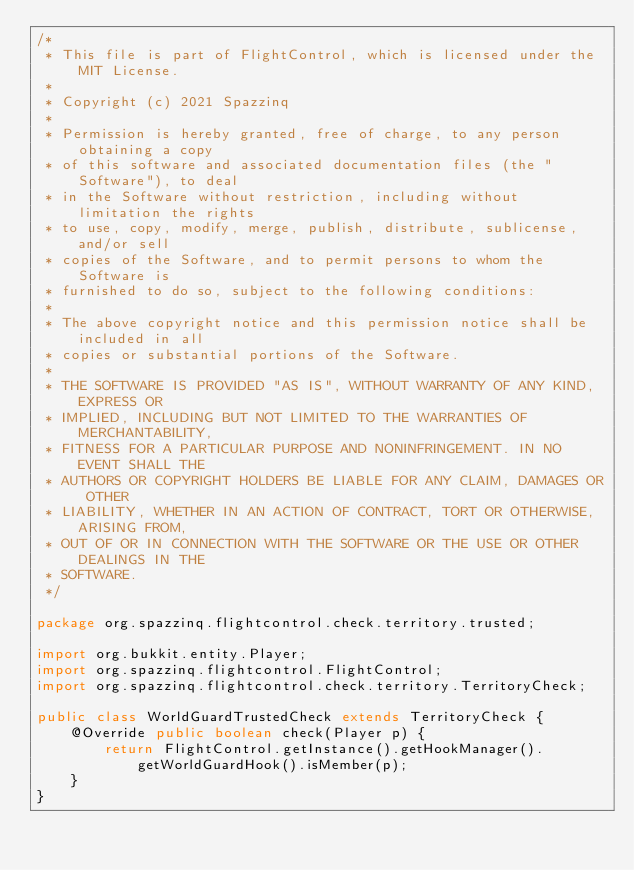<code> <loc_0><loc_0><loc_500><loc_500><_Java_>/*
 * This file is part of FlightControl, which is licensed under the MIT License.
 *
 * Copyright (c) 2021 Spazzinq
 *
 * Permission is hereby granted, free of charge, to any person obtaining a copy
 * of this software and associated documentation files (the "Software"), to deal
 * in the Software without restriction, including without limitation the rights
 * to use, copy, modify, merge, publish, distribute, sublicense, and/or sell
 * copies of the Software, and to permit persons to whom the Software is
 * furnished to do so, subject to the following conditions:
 *
 * The above copyright notice and this permission notice shall be included in all
 * copies or substantial portions of the Software.
 *
 * THE SOFTWARE IS PROVIDED "AS IS", WITHOUT WARRANTY OF ANY KIND, EXPRESS OR
 * IMPLIED, INCLUDING BUT NOT LIMITED TO THE WARRANTIES OF MERCHANTABILITY,
 * FITNESS FOR A PARTICULAR PURPOSE AND NONINFRINGEMENT. IN NO EVENT SHALL THE
 * AUTHORS OR COPYRIGHT HOLDERS BE LIABLE FOR ANY CLAIM, DAMAGES OR OTHER
 * LIABILITY, WHETHER IN AN ACTION OF CONTRACT, TORT OR OTHERWISE, ARISING FROM,
 * OUT OF OR IN CONNECTION WITH THE SOFTWARE OR THE USE OR OTHER DEALINGS IN THE
 * SOFTWARE.
 */

package org.spazzinq.flightcontrol.check.territory.trusted;

import org.bukkit.entity.Player;
import org.spazzinq.flightcontrol.FlightControl;
import org.spazzinq.flightcontrol.check.territory.TerritoryCheck;

public class WorldGuardTrustedCheck extends TerritoryCheck {
    @Override public boolean check(Player p) {
        return FlightControl.getInstance().getHookManager().getWorldGuardHook().isMember(p);
    }
}
</code> 